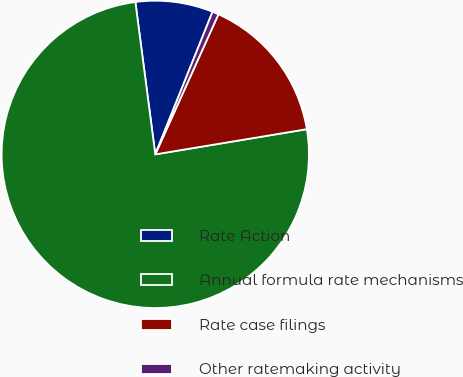<chart> <loc_0><loc_0><loc_500><loc_500><pie_chart><fcel>Rate Action<fcel>Annual formula rate mechanisms<fcel>Rate case filings<fcel>Other ratemaking activity<nl><fcel>8.15%<fcel>75.56%<fcel>15.64%<fcel>0.66%<nl></chart> 